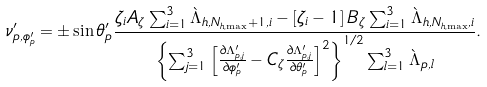Convert formula to latex. <formula><loc_0><loc_0><loc_500><loc_500>\nu ^ { \prime } _ { p , \phi ^ { \prime } _ { p } } & = \pm \sin \theta ^ { \prime } _ { p } \frac { \zeta _ { i } A _ { \zeta } \sum _ { i = 1 } ^ { 3 } \grave { \Lambda } _ { h , N _ { h , \max } + 1 , i } - \left [ \zeta _ { i } - 1 \right ] B _ { \zeta } \sum _ { i = 1 } ^ { 3 } \grave { \Lambda } _ { h , N _ { h , \max } , i } } { \left \{ \sum _ { j = 1 } ^ { 3 } \left [ \frac { \partial \Lambda ^ { \prime } _ { p , j } } { \partial \phi ^ { \prime } _ { p } } - C _ { \zeta } \frac { \partial \Lambda ^ { \prime } _ { p , j } } { \partial \theta ^ { \prime } _ { p } } \right ] ^ { 2 } \right \} ^ { 1 / 2 } \sum _ { l = 1 } ^ { 3 } \grave { \Lambda } _ { p , l } } .</formula> 